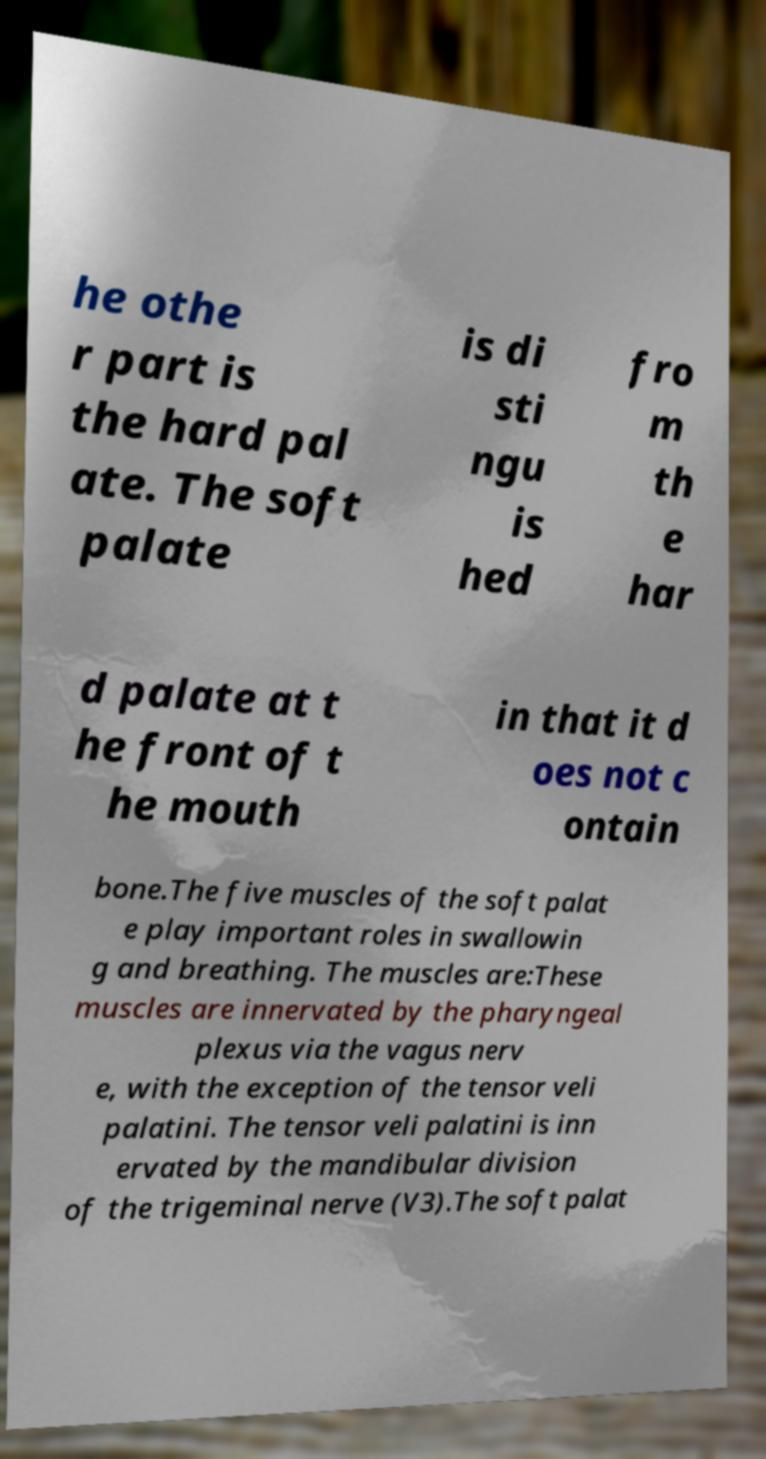Please identify and transcribe the text found in this image. he othe r part is the hard pal ate. The soft palate is di sti ngu is hed fro m th e har d palate at t he front of t he mouth in that it d oes not c ontain bone.The five muscles of the soft palat e play important roles in swallowin g and breathing. The muscles are:These muscles are innervated by the pharyngeal plexus via the vagus nerv e, with the exception of the tensor veli palatini. The tensor veli palatini is inn ervated by the mandibular division of the trigeminal nerve (V3).The soft palat 